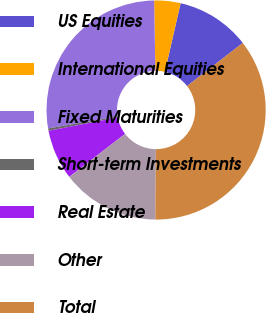<chart> <loc_0><loc_0><loc_500><loc_500><pie_chart><fcel>US Equities<fcel>International Equities<fcel>Fixed Maturities<fcel>Short-term Investments<fcel>Real Estate<fcel>Other<fcel>Total<nl><fcel>10.93%<fcel>3.88%<fcel>27.4%<fcel>0.36%<fcel>7.4%<fcel>14.45%<fcel>35.59%<nl></chart> 